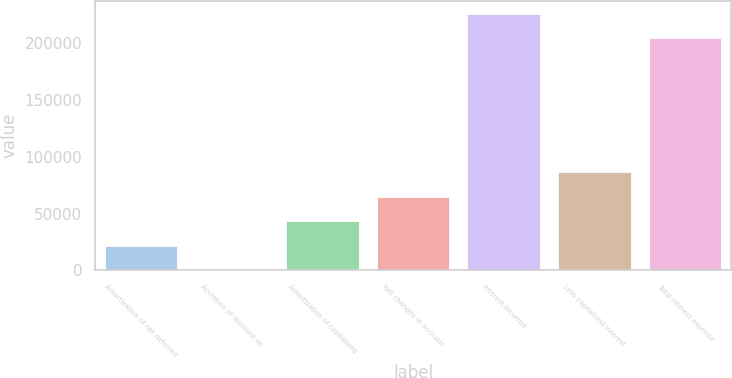<chart> <loc_0><loc_0><loc_500><loc_500><bar_chart><fcel>Amortization of net deferred<fcel>Accretion of discount on<fcel>Amortization of capitalized<fcel>Net changes in accruals<fcel>Interest incurred<fcel>Less capitalized interest<fcel>Total interest expense<nl><fcel>21738.3<fcel>257<fcel>43219.6<fcel>64700.9<fcel>225703<fcel>86182.2<fcel>204222<nl></chart> 